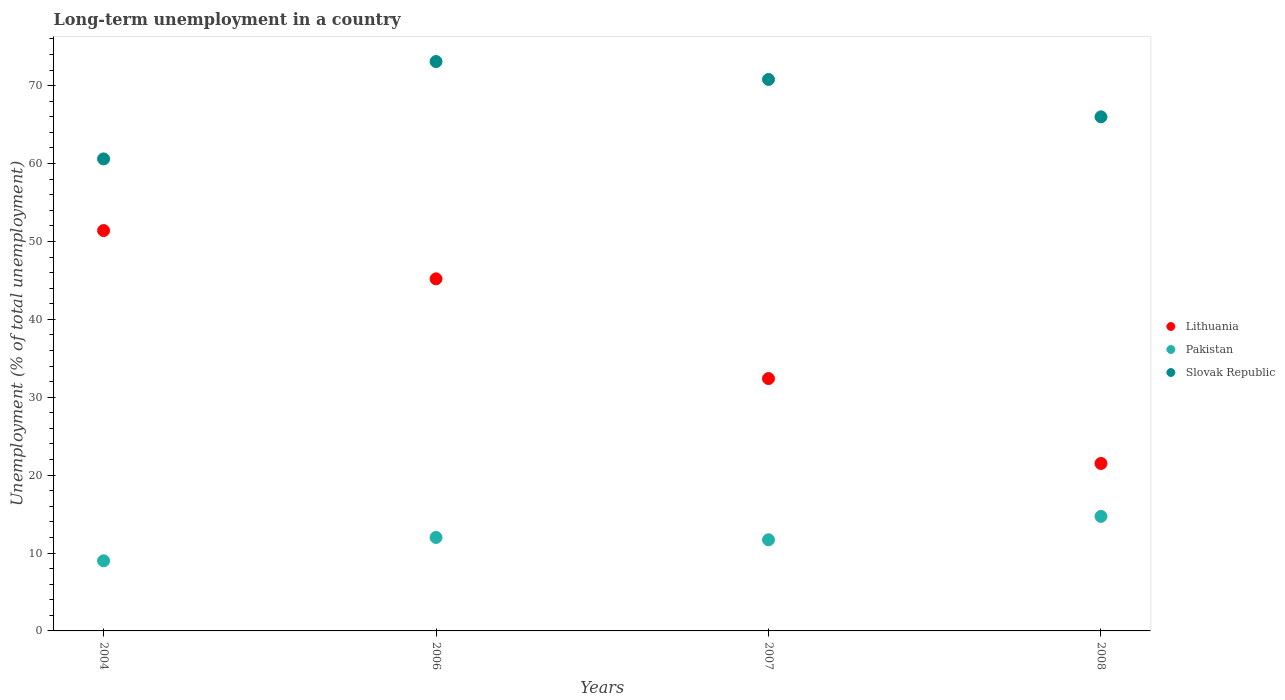Is the number of dotlines equal to the number of legend labels?
Your answer should be compact. Yes. What is the percentage of long-term unemployed population in Pakistan in 2008?
Give a very brief answer. 14.7. Across all years, what is the maximum percentage of long-term unemployed population in Lithuania?
Keep it short and to the point. 51.4. What is the total percentage of long-term unemployed population in Lithuania in the graph?
Provide a short and direct response. 150.5. What is the difference between the percentage of long-term unemployed population in Slovak Republic in 2004 and that in 2007?
Give a very brief answer. -10.2. What is the difference between the percentage of long-term unemployed population in Pakistan in 2004 and the percentage of long-term unemployed population in Slovak Republic in 2008?
Keep it short and to the point. -57. What is the average percentage of long-term unemployed population in Lithuania per year?
Your answer should be very brief. 37.63. In the year 2004, what is the difference between the percentage of long-term unemployed population in Lithuania and percentage of long-term unemployed population in Slovak Republic?
Offer a very short reply. -9.2. What is the ratio of the percentage of long-term unemployed population in Pakistan in 2006 to that in 2008?
Give a very brief answer. 0.82. Is the difference between the percentage of long-term unemployed population in Lithuania in 2006 and 2008 greater than the difference between the percentage of long-term unemployed population in Slovak Republic in 2006 and 2008?
Give a very brief answer. Yes. What is the difference between the highest and the second highest percentage of long-term unemployed population in Slovak Republic?
Your answer should be compact. 2.3. What is the difference between the highest and the lowest percentage of long-term unemployed population in Pakistan?
Your response must be concise. 5.7. Is the sum of the percentage of long-term unemployed population in Slovak Republic in 2004 and 2006 greater than the maximum percentage of long-term unemployed population in Lithuania across all years?
Give a very brief answer. Yes. Is it the case that in every year, the sum of the percentage of long-term unemployed population in Slovak Republic and percentage of long-term unemployed population in Lithuania  is greater than the percentage of long-term unemployed population in Pakistan?
Offer a very short reply. Yes. Is the percentage of long-term unemployed population in Pakistan strictly less than the percentage of long-term unemployed population in Lithuania over the years?
Provide a succinct answer. Yes. How many years are there in the graph?
Keep it short and to the point. 4. What is the difference between two consecutive major ticks on the Y-axis?
Provide a short and direct response. 10. Are the values on the major ticks of Y-axis written in scientific E-notation?
Your answer should be compact. No. Does the graph contain grids?
Make the answer very short. No. Where does the legend appear in the graph?
Your response must be concise. Center right. How many legend labels are there?
Ensure brevity in your answer.  3. How are the legend labels stacked?
Offer a very short reply. Vertical. What is the title of the graph?
Your answer should be very brief. Long-term unemployment in a country. Does "Poland" appear as one of the legend labels in the graph?
Your answer should be very brief. No. What is the label or title of the X-axis?
Offer a terse response. Years. What is the label or title of the Y-axis?
Keep it short and to the point. Unemployment (% of total unemployment). What is the Unemployment (% of total unemployment) of Lithuania in 2004?
Ensure brevity in your answer.  51.4. What is the Unemployment (% of total unemployment) in Slovak Republic in 2004?
Ensure brevity in your answer.  60.6. What is the Unemployment (% of total unemployment) in Lithuania in 2006?
Provide a succinct answer. 45.2. What is the Unemployment (% of total unemployment) of Slovak Republic in 2006?
Your answer should be compact. 73.1. What is the Unemployment (% of total unemployment) of Lithuania in 2007?
Your answer should be very brief. 32.4. What is the Unemployment (% of total unemployment) of Pakistan in 2007?
Offer a very short reply. 11.7. What is the Unemployment (% of total unemployment) of Slovak Republic in 2007?
Your answer should be very brief. 70.8. What is the Unemployment (% of total unemployment) in Lithuania in 2008?
Make the answer very short. 21.5. What is the Unemployment (% of total unemployment) of Pakistan in 2008?
Your answer should be very brief. 14.7. What is the Unemployment (% of total unemployment) in Slovak Republic in 2008?
Offer a terse response. 66. Across all years, what is the maximum Unemployment (% of total unemployment) of Lithuania?
Offer a terse response. 51.4. Across all years, what is the maximum Unemployment (% of total unemployment) of Pakistan?
Give a very brief answer. 14.7. Across all years, what is the maximum Unemployment (% of total unemployment) of Slovak Republic?
Your response must be concise. 73.1. Across all years, what is the minimum Unemployment (% of total unemployment) in Slovak Republic?
Offer a very short reply. 60.6. What is the total Unemployment (% of total unemployment) in Lithuania in the graph?
Give a very brief answer. 150.5. What is the total Unemployment (% of total unemployment) of Pakistan in the graph?
Provide a short and direct response. 47.4. What is the total Unemployment (% of total unemployment) of Slovak Republic in the graph?
Your response must be concise. 270.5. What is the difference between the Unemployment (% of total unemployment) in Lithuania in 2004 and that in 2006?
Provide a succinct answer. 6.2. What is the difference between the Unemployment (% of total unemployment) of Lithuania in 2004 and that in 2007?
Provide a short and direct response. 19. What is the difference between the Unemployment (% of total unemployment) in Slovak Republic in 2004 and that in 2007?
Keep it short and to the point. -10.2. What is the difference between the Unemployment (% of total unemployment) in Lithuania in 2004 and that in 2008?
Your response must be concise. 29.9. What is the difference between the Unemployment (% of total unemployment) in Lithuania in 2006 and that in 2007?
Offer a terse response. 12.8. What is the difference between the Unemployment (% of total unemployment) in Pakistan in 2006 and that in 2007?
Ensure brevity in your answer.  0.3. What is the difference between the Unemployment (% of total unemployment) of Slovak Republic in 2006 and that in 2007?
Provide a succinct answer. 2.3. What is the difference between the Unemployment (% of total unemployment) in Lithuania in 2006 and that in 2008?
Your answer should be very brief. 23.7. What is the difference between the Unemployment (% of total unemployment) in Pakistan in 2006 and that in 2008?
Provide a succinct answer. -2.7. What is the difference between the Unemployment (% of total unemployment) in Slovak Republic in 2006 and that in 2008?
Provide a short and direct response. 7.1. What is the difference between the Unemployment (% of total unemployment) of Slovak Republic in 2007 and that in 2008?
Ensure brevity in your answer.  4.8. What is the difference between the Unemployment (% of total unemployment) of Lithuania in 2004 and the Unemployment (% of total unemployment) of Pakistan in 2006?
Keep it short and to the point. 39.4. What is the difference between the Unemployment (% of total unemployment) of Lithuania in 2004 and the Unemployment (% of total unemployment) of Slovak Republic in 2006?
Give a very brief answer. -21.7. What is the difference between the Unemployment (% of total unemployment) in Pakistan in 2004 and the Unemployment (% of total unemployment) in Slovak Republic in 2006?
Give a very brief answer. -64.1. What is the difference between the Unemployment (% of total unemployment) in Lithuania in 2004 and the Unemployment (% of total unemployment) in Pakistan in 2007?
Ensure brevity in your answer.  39.7. What is the difference between the Unemployment (% of total unemployment) of Lithuania in 2004 and the Unemployment (% of total unemployment) of Slovak Republic in 2007?
Your answer should be very brief. -19.4. What is the difference between the Unemployment (% of total unemployment) in Pakistan in 2004 and the Unemployment (% of total unemployment) in Slovak Republic in 2007?
Your answer should be very brief. -61.8. What is the difference between the Unemployment (% of total unemployment) of Lithuania in 2004 and the Unemployment (% of total unemployment) of Pakistan in 2008?
Offer a terse response. 36.7. What is the difference between the Unemployment (% of total unemployment) of Lithuania in 2004 and the Unemployment (% of total unemployment) of Slovak Republic in 2008?
Offer a terse response. -14.6. What is the difference between the Unemployment (% of total unemployment) of Pakistan in 2004 and the Unemployment (% of total unemployment) of Slovak Republic in 2008?
Keep it short and to the point. -57. What is the difference between the Unemployment (% of total unemployment) of Lithuania in 2006 and the Unemployment (% of total unemployment) of Pakistan in 2007?
Give a very brief answer. 33.5. What is the difference between the Unemployment (% of total unemployment) of Lithuania in 2006 and the Unemployment (% of total unemployment) of Slovak Republic in 2007?
Ensure brevity in your answer.  -25.6. What is the difference between the Unemployment (% of total unemployment) of Pakistan in 2006 and the Unemployment (% of total unemployment) of Slovak Republic in 2007?
Offer a terse response. -58.8. What is the difference between the Unemployment (% of total unemployment) of Lithuania in 2006 and the Unemployment (% of total unemployment) of Pakistan in 2008?
Offer a very short reply. 30.5. What is the difference between the Unemployment (% of total unemployment) of Lithuania in 2006 and the Unemployment (% of total unemployment) of Slovak Republic in 2008?
Keep it short and to the point. -20.8. What is the difference between the Unemployment (% of total unemployment) of Pakistan in 2006 and the Unemployment (% of total unemployment) of Slovak Republic in 2008?
Provide a succinct answer. -54. What is the difference between the Unemployment (% of total unemployment) of Lithuania in 2007 and the Unemployment (% of total unemployment) of Slovak Republic in 2008?
Ensure brevity in your answer.  -33.6. What is the difference between the Unemployment (% of total unemployment) in Pakistan in 2007 and the Unemployment (% of total unemployment) in Slovak Republic in 2008?
Ensure brevity in your answer.  -54.3. What is the average Unemployment (% of total unemployment) in Lithuania per year?
Your answer should be very brief. 37.62. What is the average Unemployment (% of total unemployment) in Pakistan per year?
Your response must be concise. 11.85. What is the average Unemployment (% of total unemployment) of Slovak Republic per year?
Keep it short and to the point. 67.62. In the year 2004, what is the difference between the Unemployment (% of total unemployment) in Lithuania and Unemployment (% of total unemployment) in Pakistan?
Provide a succinct answer. 42.4. In the year 2004, what is the difference between the Unemployment (% of total unemployment) in Pakistan and Unemployment (% of total unemployment) in Slovak Republic?
Provide a short and direct response. -51.6. In the year 2006, what is the difference between the Unemployment (% of total unemployment) of Lithuania and Unemployment (% of total unemployment) of Pakistan?
Offer a very short reply. 33.2. In the year 2006, what is the difference between the Unemployment (% of total unemployment) of Lithuania and Unemployment (% of total unemployment) of Slovak Republic?
Your response must be concise. -27.9. In the year 2006, what is the difference between the Unemployment (% of total unemployment) of Pakistan and Unemployment (% of total unemployment) of Slovak Republic?
Your answer should be compact. -61.1. In the year 2007, what is the difference between the Unemployment (% of total unemployment) in Lithuania and Unemployment (% of total unemployment) in Pakistan?
Your answer should be very brief. 20.7. In the year 2007, what is the difference between the Unemployment (% of total unemployment) of Lithuania and Unemployment (% of total unemployment) of Slovak Republic?
Your response must be concise. -38.4. In the year 2007, what is the difference between the Unemployment (% of total unemployment) in Pakistan and Unemployment (% of total unemployment) in Slovak Republic?
Give a very brief answer. -59.1. In the year 2008, what is the difference between the Unemployment (% of total unemployment) of Lithuania and Unemployment (% of total unemployment) of Slovak Republic?
Provide a short and direct response. -44.5. In the year 2008, what is the difference between the Unemployment (% of total unemployment) in Pakistan and Unemployment (% of total unemployment) in Slovak Republic?
Provide a short and direct response. -51.3. What is the ratio of the Unemployment (% of total unemployment) of Lithuania in 2004 to that in 2006?
Ensure brevity in your answer.  1.14. What is the ratio of the Unemployment (% of total unemployment) of Slovak Republic in 2004 to that in 2006?
Keep it short and to the point. 0.83. What is the ratio of the Unemployment (% of total unemployment) in Lithuania in 2004 to that in 2007?
Ensure brevity in your answer.  1.59. What is the ratio of the Unemployment (% of total unemployment) in Pakistan in 2004 to that in 2007?
Make the answer very short. 0.77. What is the ratio of the Unemployment (% of total unemployment) of Slovak Republic in 2004 to that in 2007?
Make the answer very short. 0.86. What is the ratio of the Unemployment (% of total unemployment) in Lithuania in 2004 to that in 2008?
Your answer should be compact. 2.39. What is the ratio of the Unemployment (% of total unemployment) in Pakistan in 2004 to that in 2008?
Provide a succinct answer. 0.61. What is the ratio of the Unemployment (% of total unemployment) of Slovak Republic in 2004 to that in 2008?
Offer a very short reply. 0.92. What is the ratio of the Unemployment (% of total unemployment) in Lithuania in 2006 to that in 2007?
Your answer should be very brief. 1.4. What is the ratio of the Unemployment (% of total unemployment) in Pakistan in 2006 to that in 2007?
Offer a very short reply. 1.03. What is the ratio of the Unemployment (% of total unemployment) in Slovak Republic in 2006 to that in 2007?
Make the answer very short. 1.03. What is the ratio of the Unemployment (% of total unemployment) in Lithuania in 2006 to that in 2008?
Keep it short and to the point. 2.1. What is the ratio of the Unemployment (% of total unemployment) of Pakistan in 2006 to that in 2008?
Give a very brief answer. 0.82. What is the ratio of the Unemployment (% of total unemployment) of Slovak Republic in 2006 to that in 2008?
Provide a succinct answer. 1.11. What is the ratio of the Unemployment (% of total unemployment) in Lithuania in 2007 to that in 2008?
Ensure brevity in your answer.  1.51. What is the ratio of the Unemployment (% of total unemployment) in Pakistan in 2007 to that in 2008?
Your answer should be compact. 0.8. What is the ratio of the Unemployment (% of total unemployment) of Slovak Republic in 2007 to that in 2008?
Give a very brief answer. 1.07. What is the difference between the highest and the second highest Unemployment (% of total unemployment) in Lithuania?
Keep it short and to the point. 6.2. What is the difference between the highest and the lowest Unemployment (% of total unemployment) of Lithuania?
Your answer should be compact. 29.9. What is the difference between the highest and the lowest Unemployment (% of total unemployment) of Pakistan?
Provide a short and direct response. 5.7. 